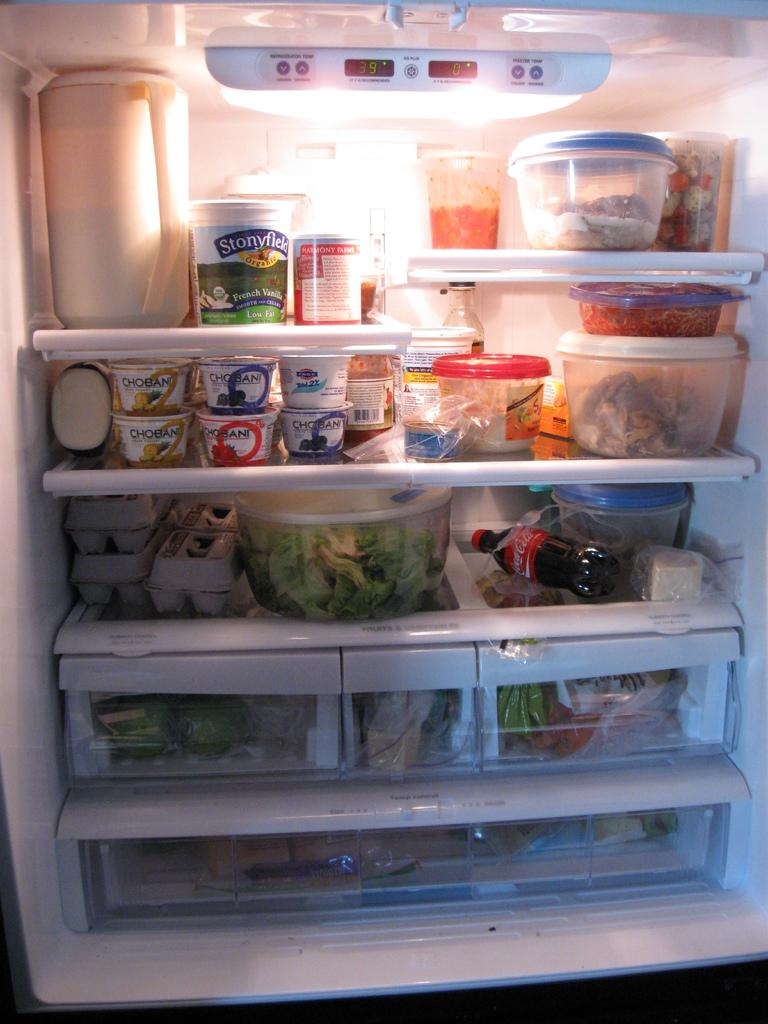Provide a one-sentence caption for the provided image. The refrigerator is filled with healthy foods like greek yogurt, eggs and vegetables. 